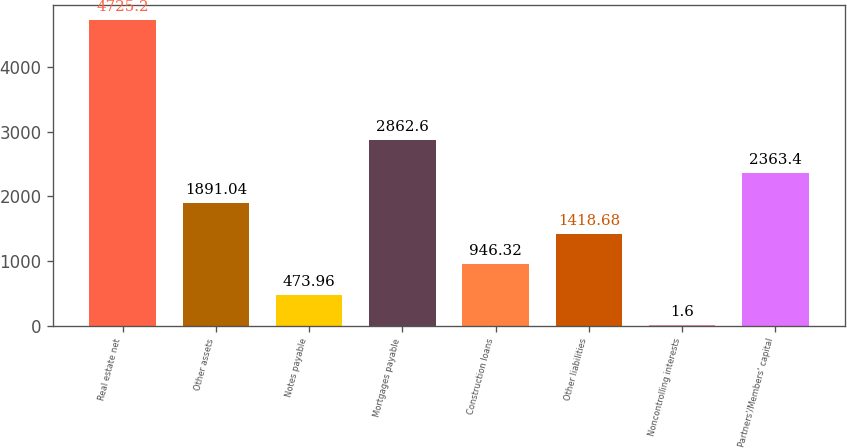Convert chart to OTSL. <chart><loc_0><loc_0><loc_500><loc_500><bar_chart><fcel>Real estate net<fcel>Other assets<fcel>Notes payable<fcel>Mortgages payable<fcel>Construction loans<fcel>Other liabilities<fcel>Noncontrolling interests<fcel>Partners'/Members' capital<nl><fcel>4725.2<fcel>1891.04<fcel>473.96<fcel>2862.6<fcel>946.32<fcel>1418.68<fcel>1.6<fcel>2363.4<nl></chart> 